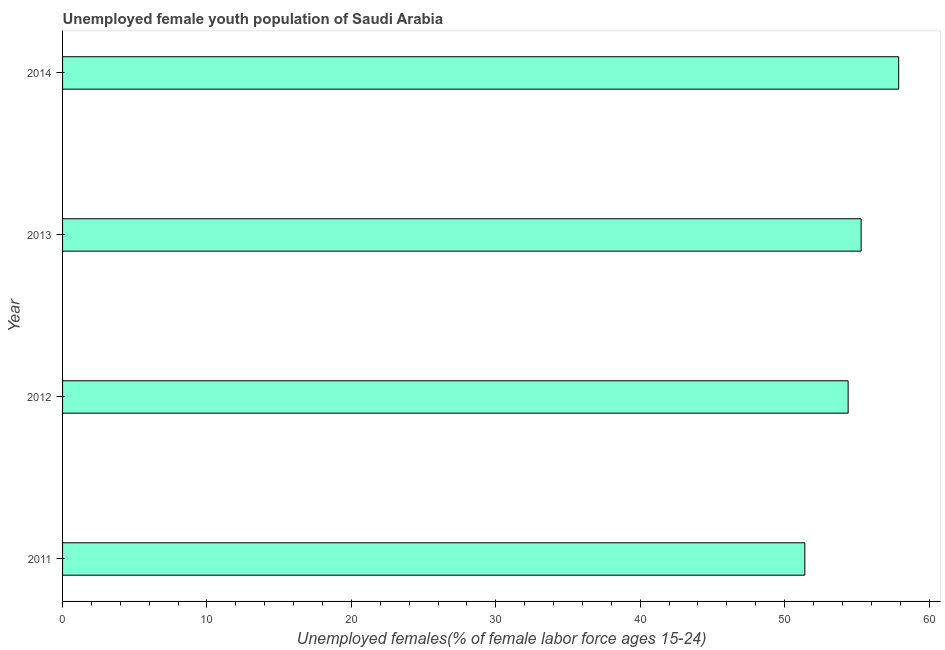What is the title of the graph?
Keep it short and to the point. Unemployed female youth population of Saudi Arabia. What is the label or title of the X-axis?
Ensure brevity in your answer.  Unemployed females(% of female labor force ages 15-24). What is the label or title of the Y-axis?
Ensure brevity in your answer.  Year. What is the unemployed female youth in 2011?
Offer a terse response. 51.4. Across all years, what is the maximum unemployed female youth?
Ensure brevity in your answer.  57.9. Across all years, what is the minimum unemployed female youth?
Provide a succinct answer. 51.4. What is the sum of the unemployed female youth?
Offer a very short reply. 219. What is the difference between the unemployed female youth in 2011 and 2012?
Provide a succinct answer. -3. What is the average unemployed female youth per year?
Offer a terse response. 54.75. What is the median unemployed female youth?
Make the answer very short. 54.85. In how many years, is the unemployed female youth greater than 36 %?
Your response must be concise. 4. Do a majority of the years between 2014 and 2012 (inclusive) have unemployed female youth greater than 20 %?
Offer a terse response. Yes. What is the ratio of the unemployed female youth in 2012 to that in 2014?
Give a very brief answer. 0.94. Is the unemployed female youth in 2013 less than that in 2014?
Your answer should be compact. Yes. Is the sum of the unemployed female youth in 2011 and 2012 greater than the maximum unemployed female youth across all years?
Make the answer very short. Yes. What is the difference between the highest and the lowest unemployed female youth?
Offer a very short reply. 6.5. How many bars are there?
Provide a succinct answer. 4. Are all the bars in the graph horizontal?
Offer a very short reply. Yes. What is the difference between two consecutive major ticks on the X-axis?
Ensure brevity in your answer.  10. What is the Unemployed females(% of female labor force ages 15-24) in 2011?
Ensure brevity in your answer.  51.4. What is the Unemployed females(% of female labor force ages 15-24) of 2012?
Your response must be concise. 54.4. What is the Unemployed females(% of female labor force ages 15-24) of 2013?
Ensure brevity in your answer.  55.3. What is the Unemployed females(% of female labor force ages 15-24) in 2014?
Provide a short and direct response. 57.9. What is the difference between the Unemployed females(% of female labor force ages 15-24) in 2011 and 2012?
Give a very brief answer. -3. What is the difference between the Unemployed females(% of female labor force ages 15-24) in 2011 and 2013?
Ensure brevity in your answer.  -3.9. What is the difference between the Unemployed females(% of female labor force ages 15-24) in 2011 and 2014?
Provide a short and direct response. -6.5. What is the difference between the Unemployed females(% of female labor force ages 15-24) in 2012 and 2013?
Your answer should be compact. -0.9. What is the difference between the Unemployed females(% of female labor force ages 15-24) in 2012 and 2014?
Give a very brief answer. -3.5. What is the difference between the Unemployed females(% of female labor force ages 15-24) in 2013 and 2014?
Make the answer very short. -2.6. What is the ratio of the Unemployed females(% of female labor force ages 15-24) in 2011 to that in 2012?
Your answer should be compact. 0.94. What is the ratio of the Unemployed females(% of female labor force ages 15-24) in 2011 to that in 2013?
Your response must be concise. 0.93. What is the ratio of the Unemployed females(% of female labor force ages 15-24) in 2011 to that in 2014?
Your response must be concise. 0.89. What is the ratio of the Unemployed females(% of female labor force ages 15-24) in 2012 to that in 2013?
Your answer should be compact. 0.98. What is the ratio of the Unemployed females(% of female labor force ages 15-24) in 2013 to that in 2014?
Offer a very short reply. 0.95. 